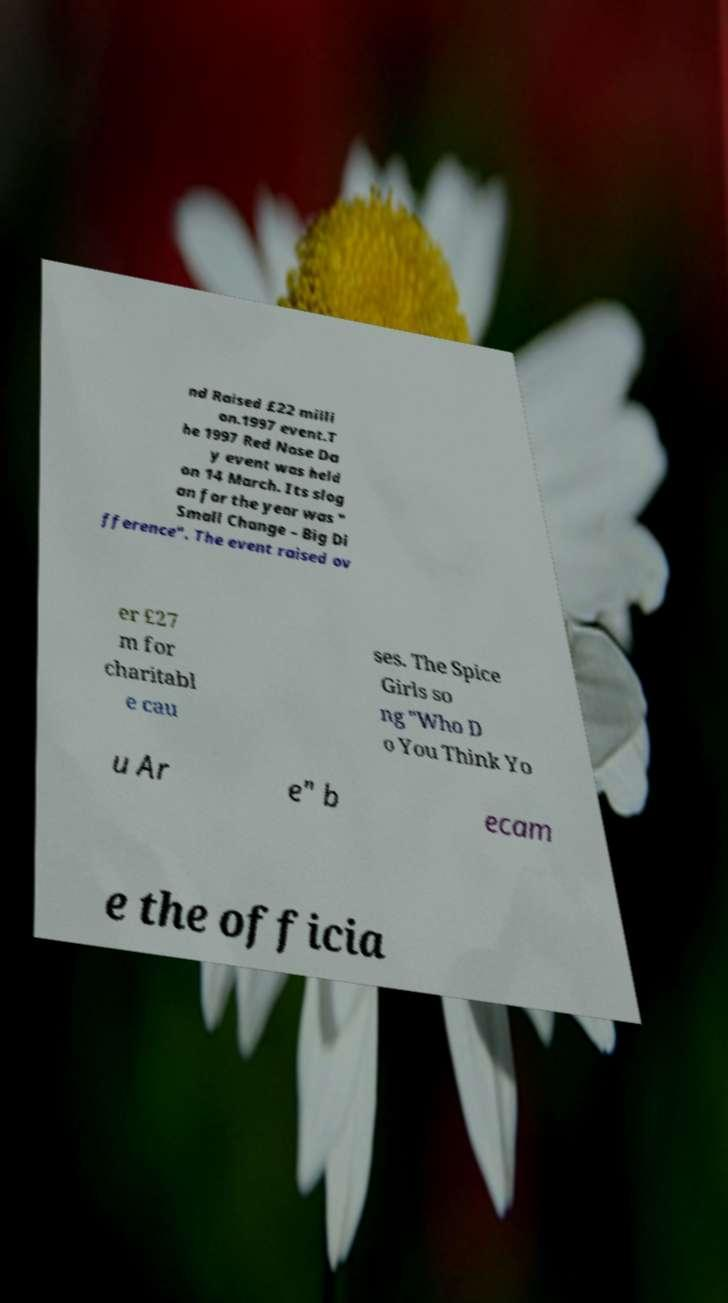Could you assist in decoding the text presented in this image and type it out clearly? nd Raised £22 milli on.1997 event.T he 1997 Red Nose Da y event was held on 14 March. Its slog an for the year was " Small Change – Big Di fference". The event raised ov er £27 m for charitabl e cau ses. The Spice Girls so ng "Who D o You Think Yo u Ar e" b ecam e the officia 